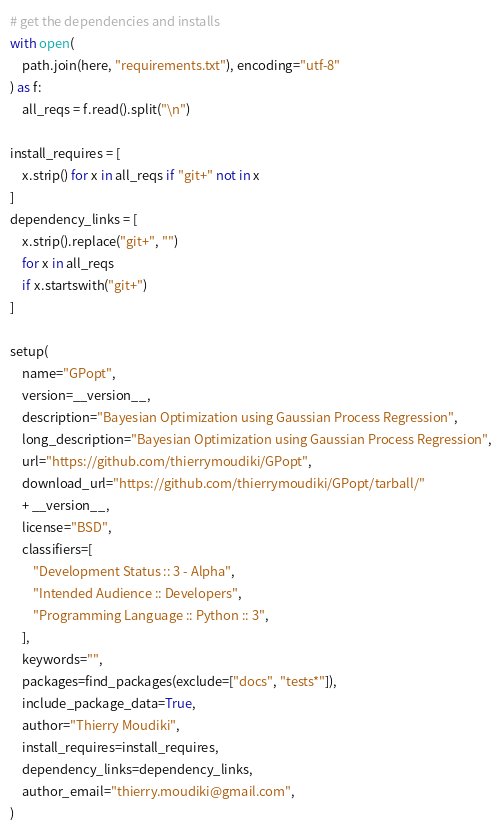<code> <loc_0><loc_0><loc_500><loc_500><_Python_># get the dependencies and installs
with open(
    path.join(here, "requirements.txt"), encoding="utf-8"
) as f:
    all_reqs = f.read().split("\n")

install_requires = [
    x.strip() for x in all_reqs if "git+" not in x
]
dependency_links = [
    x.strip().replace("git+", "")
    for x in all_reqs
    if x.startswith("git+")
]

setup(
    name="GPopt",
    version=__version__,
    description="Bayesian Optimization using Gaussian Process Regression",
    long_description="Bayesian Optimization using Gaussian Process Regression",
    url="https://github.com/thierrymoudiki/GPopt",
    download_url="https://github.com/thierrymoudiki/GPopt/tarball/"
    + __version__,
    license="BSD",
    classifiers=[
        "Development Status :: 3 - Alpha",
        "Intended Audience :: Developers",
        "Programming Language :: Python :: 3",
    ],
    keywords="",
    packages=find_packages(exclude=["docs", "tests*"]),
    include_package_data=True,
    author="Thierry Moudiki",
    install_requires=install_requires,
    dependency_links=dependency_links,
    author_email="thierry.moudiki@gmail.com",
)
</code> 